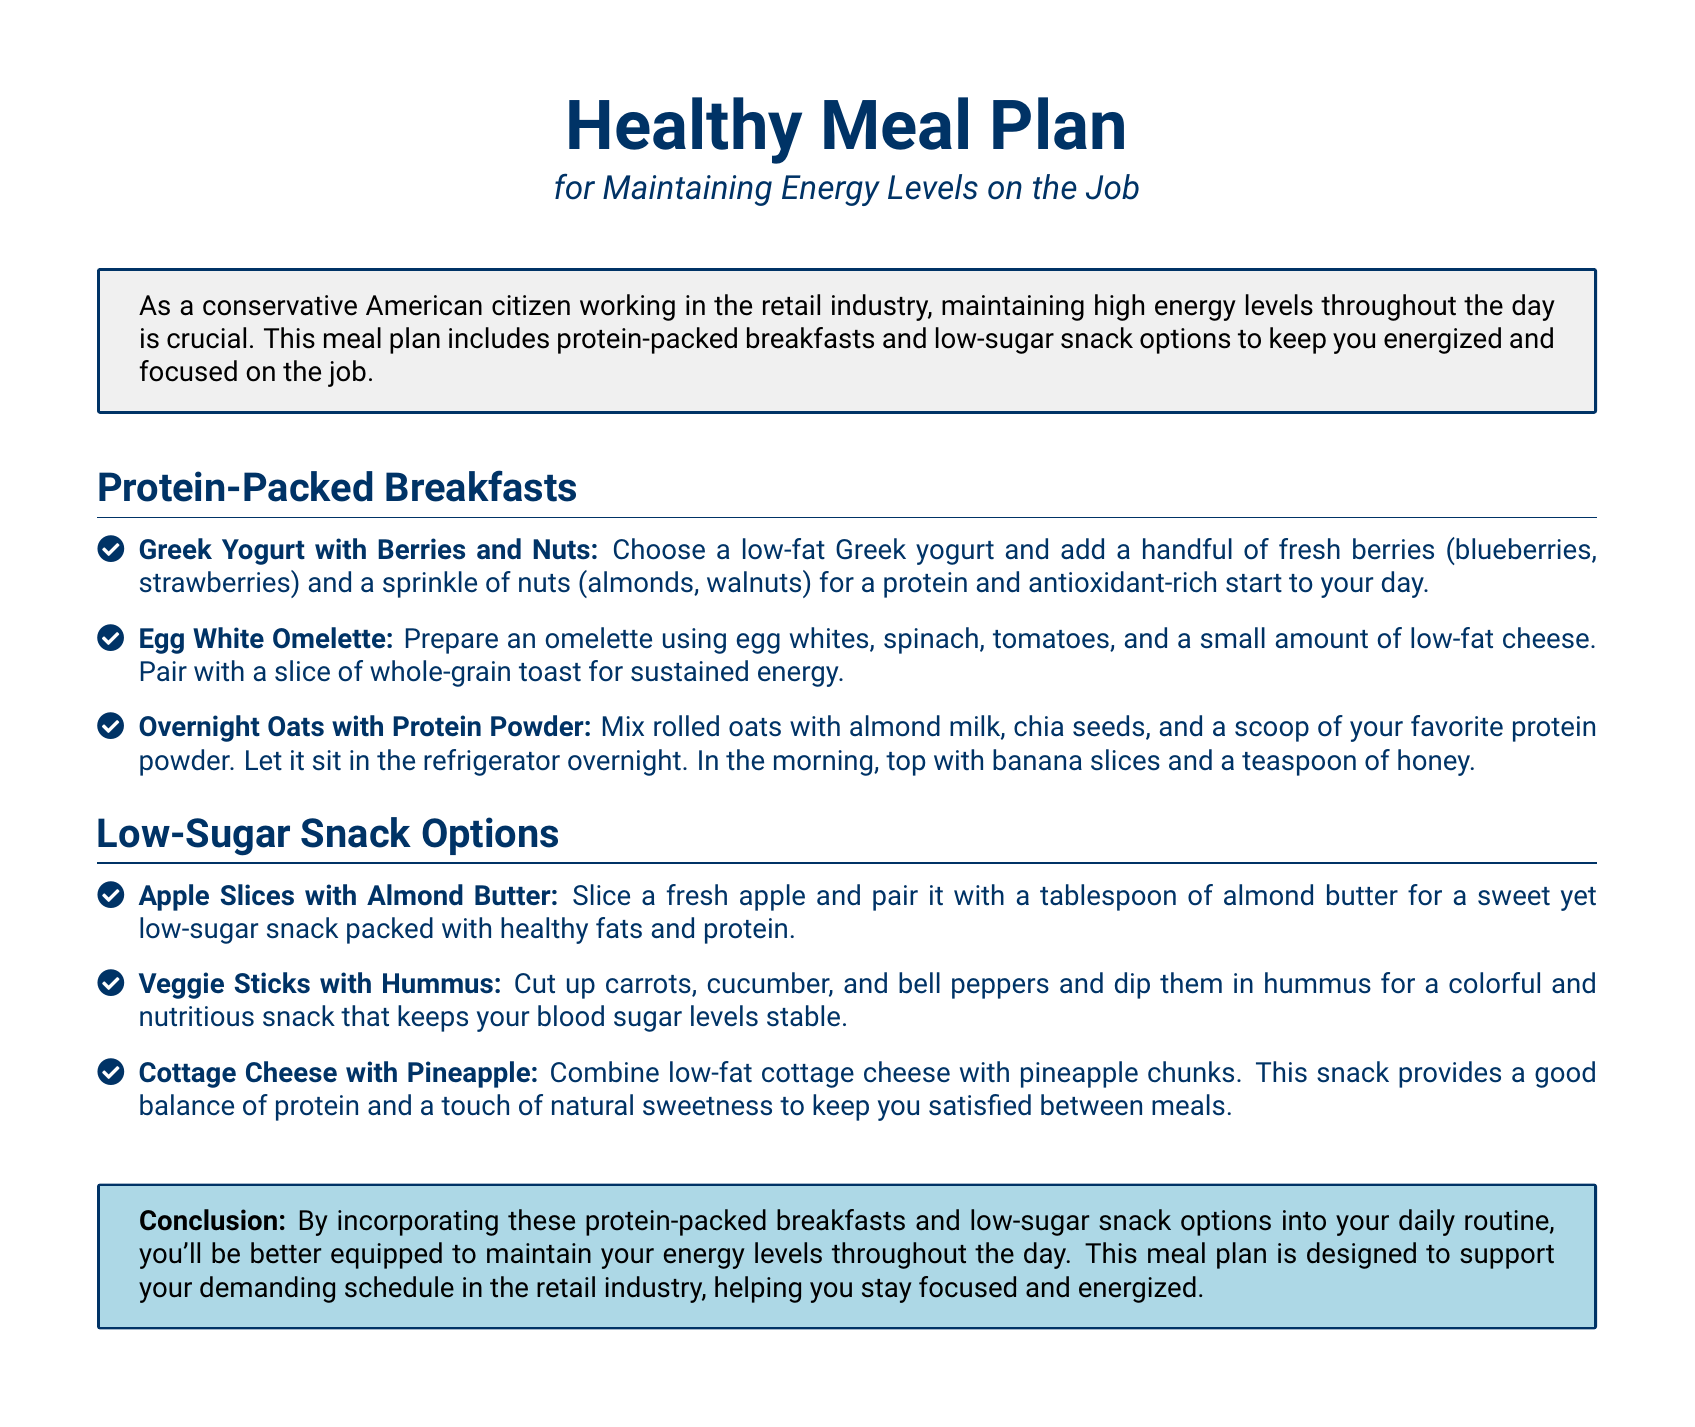What are protein-packed breakfasts? Protein-packed breakfasts are food options included in the meal plan that are rich in protein and designed to maintain energy levels.
Answer: Greek Yogurt with Berries and Nuts, Egg White Omelette, Overnight Oats with Protein Powder What kind of yogurt is recommended? The document specifies a type of yogurt that is ideal for the meal plan, focusing on health benefits.
Answer: Low-fat Greek yogurt What is a suggested topping for Overnight Oats? The meal plan includes specific toppings to enhance flavor and nutrition in Overnight Oats.
Answer: Banana slices What are low-sugar snack options? Low-sugar snack options are healthy snacks designed to provide energy without causing sugar spikes.
Answer: Apple Slices with Almond Butter, Veggie Sticks with Hummus, Cottage Cheese with Pineapple How many protein-packed breakfast options are listed? This question pertains to the quantity of breakfast options provided in the document.
Answer: Three What ingredient is paired with apple slices? The document mentions a specific type of nut butter that is recommended for pairing with apple slices to enhance nutrition.
Answer: Almond butter What is the purpose of the meal plan? The meal plan is designed with a specific goal in mind, aimed at helping individuals in their daily routines.
Answer: Maintaining energy levels Which snack option includes hummus? This question requires identifying a specific snack that features hummus as a primary component.
Answer: Veggie Sticks with Hummus What should be paired with an egg white omelette? The document suggests a specific type of bread to accompany the omelette for better energy.
Answer: Whole-grain toast 